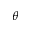Convert formula to latex. <formula><loc_0><loc_0><loc_500><loc_500>\theta</formula> 